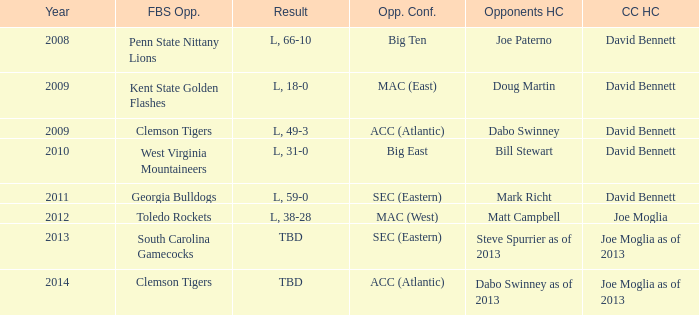How many head coaches did Kent state golden flashes have? 1.0. 